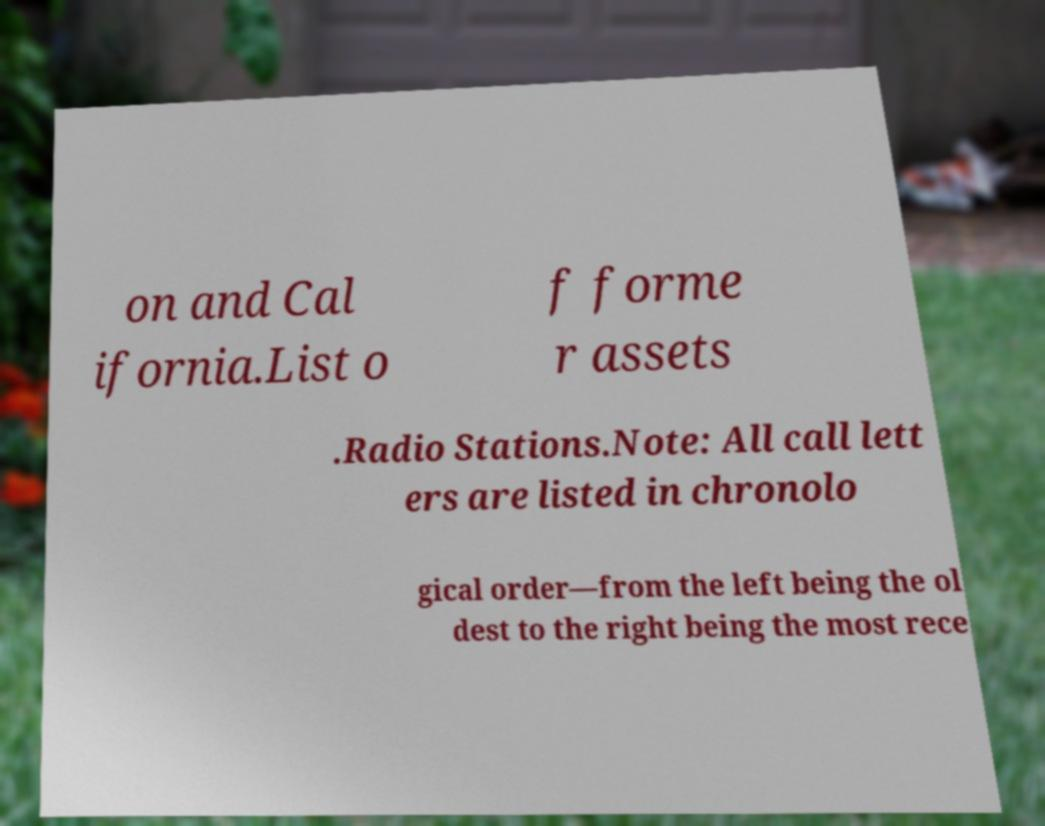Can you read and provide the text displayed in the image?This photo seems to have some interesting text. Can you extract and type it out for me? on and Cal ifornia.List o f forme r assets .Radio Stations.Note: All call lett ers are listed in chronolo gical order—from the left being the ol dest to the right being the most rece 